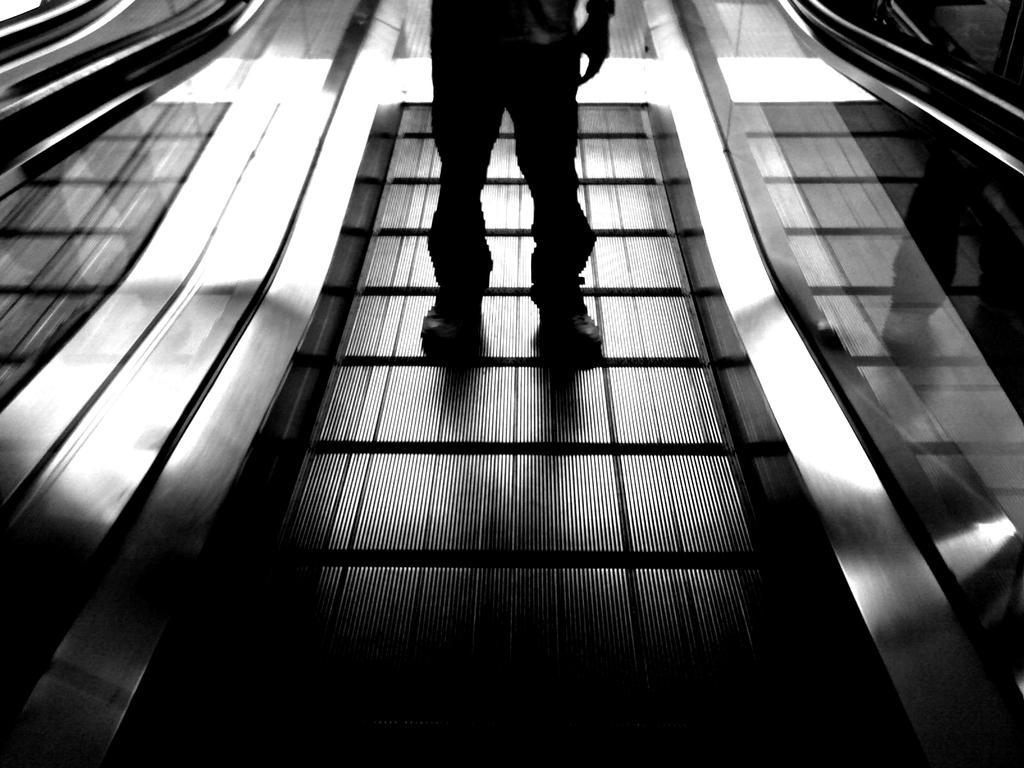In one or two sentences, can you explain what this image depicts? It looks like a black and white picture. We can see a person is standing on the escalator. On the left and right side of the person there are transparent glasses. 